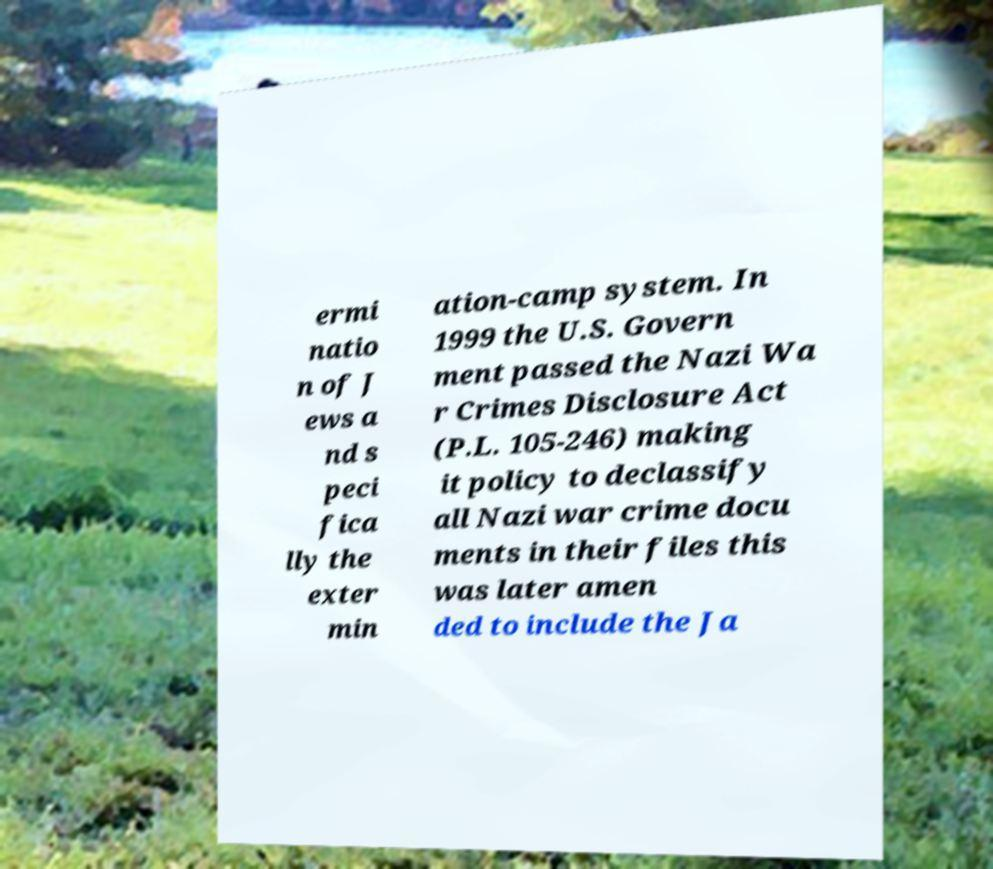Please read and relay the text visible in this image. What does it say? ermi natio n of J ews a nd s peci fica lly the exter min ation-camp system. In 1999 the U.S. Govern ment passed the Nazi Wa r Crimes Disclosure Act (P.L. 105-246) making it policy to declassify all Nazi war crime docu ments in their files this was later amen ded to include the Ja 